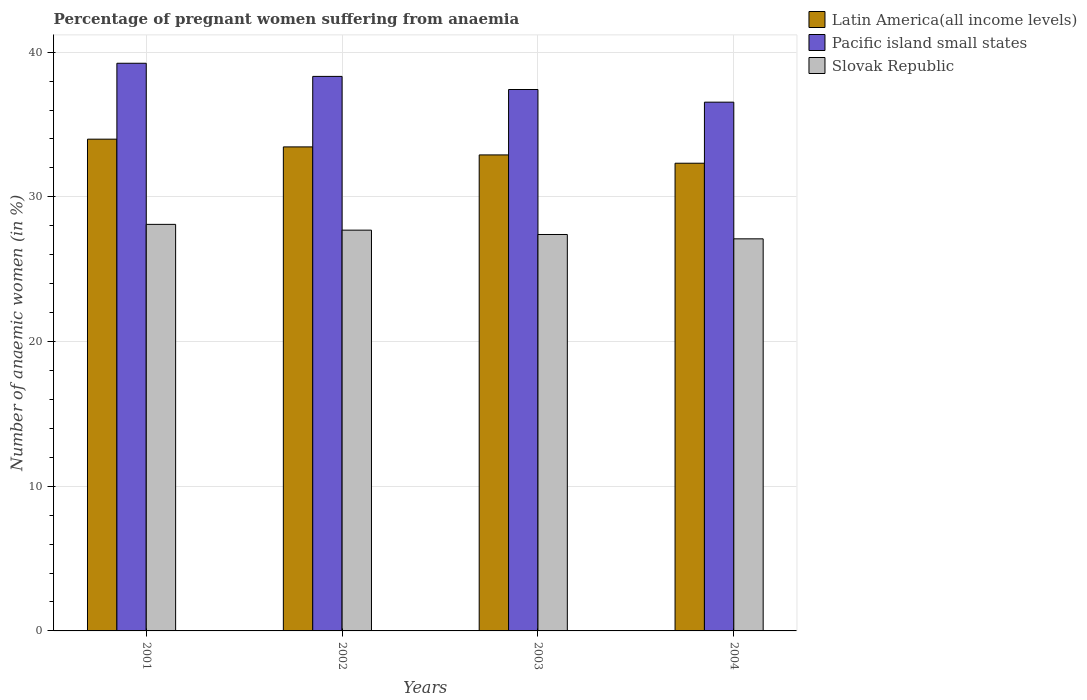How many different coloured bars are there?
Give a very brief answer. 3. Are the number of bars on each tick of the X-axis equal?
Keep it short and to the point. Yes. How many bars are there on the 2nd tick from the left?
Your response must be concise. 3. How many bars are there on the 3rd tick from the right?
Provide a short and direct response. 3. What is the number of anaemic women in Pacific island small states in 2002?
Offer a terse response. 38.33. Across all years, what is the maximum number of anaemic women in Latin America(all income levels)?
Ensure brevity in your answer.  33.99. Across all years, what is the minimum number of anaemic women in Latin America(all income levels)?
Ensure brevity in your answer.  32.33. In which year was the number of anaemic women in Latin America(all income levels) maximum?
Provide a short and direct response. 2001. In which year was the number of anaemic women in Pacific island small states minimum?
Make the answer very short. 2004. What is the total number of anaemic women in Latin America(all income levels) in the graph?
Your answer should be very brief. 132.67. What is the difference between the number of anaemic women in Slovak Republic in 2003 and that in 2004?
Provide a short and direct response. 0.3. What is the difference between the number of anaemic women in Pacific island small states in 2003 and the number of anaemic women in Slovak Republic in 2004?
Provide a succinct answer. 10.32. What is the average number of anaemic women in Slovak Republic per year?
Your answer should be very brief. 27.57. In the year 2002, what is the difference between the number of anaemic women in Latin America(all income levels) and number of anaemic women in Pacific island small states?
Offer a terse response. -4.87. What is the ratio of the number of anaemic women in Pacific island small states in 2002 to that in 2003?
Your answer should be compact. 1.02. What is the difference between the highest and the second highest number of anaemic women in Slovak Republic?
Make the answer very short. 0.4. What is the difference between the highest and the lowest number of anaemic women in Slovak Republic?
Provide a short and direct response. 1. What does the 2nd bar from the left in 2002 represents?
Offer a terse response. Pacific island small states. What does the 2nd bar from the right in 2004 represents?
Provide a short and direct response. Pacific island small states. How many years are there in the graph?
Provide a short and direct response. 4. How many legend labels are there?
Keep it short and to the point. 3. What is the title of the graph?
Make the answer very short. Percentage of pregnant women suffering from anaemia. Does "Qatar" appear as one of the legend labels in the graph?
Your answer should be compact. No. What is the label or title of the X-axis?
Make the answer very short. Years. What is the label or title of the Y-axis?
Give a very brief answer. Number of anaemic women (in %). What is the Number of anaemic women (in %) of Latin America(all income levels) in 2001?
Offer a very short reply. 33.99. What is the Number of anaemic women (in %) in Pacific island small states in 2001?
Your answer should be very brief. 39.23. What is the Number of anaemic women (in %) in Slovak Republic in 2001?
Your answer should be compact. 28.1. What is the Number of anaemic women (in %) in Latin America(all income levels) in 2002?
Ensure brevity in your answer.  33.45. What is the Number of anaemic women (in %) in Pacific island small states in 2002?
Give a very brief answer. 38.33. What is the Number of anaemic women (in %) of Slovak Republic in 2002?
Make the answer very short. 27.7. What is the Number of anaemic women (in %) of Latin America(all income levels) in 2003?
Offer a very short reply. 32.9. What is the Number of anaemic women (in %) in Pacific island small states in 2003?
Your response must be concise. 37.42. What is the Number of anaemic women (in %) in Slovak Republic in 2003?
Make the answer very short. 27.4. What is the Number of anaemic women (in %) of Latin America(all income levels) in 2004?
Your response must be concise. 32.33. What is the Number of anaemic women (in %) in Pacific island small states in 2004?
Ensure brevity in your answer.  36.55. What is the Number of anaemic women (in %) of Slovak Republic in 2004?
Your response must be concise. 27.1. Across all years, what is the maximum Number of anaemic women (in %) in Latin America(all income levels)?
Offer a terse response. 33.99. Across all years, what is the maximum Number of anaemic women (in %) of Pacific island small states?
Offer a very short reply. 39.23. Across all years, what is the maximum Number of anaemic women (in %) in Slovak Republic?
Ensure brevity in your answer.  28.1. Across all years, what is the minimum Number of anaemic women (in %) in Latin America(all income levels)?
Your answer should be very brief. 32.33. Across all years, what is the minimum Number of anaemic women (in %) of Pacific island small states?
Provide a succinct answer. 36.55. Across all years, what is the minimum Number of anaemic women (in %) of Slovak Republic?
Keep it short and to the point. 27.1. What is the total Number of anaemic women (in %) of Latin America(all income levels) in the graph?
Make the answer very short. 132.67. What is the total Number of anaemic women (in %) in Pacific island small states in the graph?
Offer a very short reply. 151.53. What is the total Number of anaemic women (in %) of Slovak Republic in the graph?
Your answer should be very brief. 110.3. What is the difference between the Number of anaemic women (in %) in Latin America(all income levels) in 2001 and that in 2002?
Give a very brief answer. 0.53. What is the difference between the Number of anaemic women (in %) of Pacific island small states in 2001 and that in 2002?
Provide a short and direct response. 0.91. What is the difference between the Number of anaemic women (in %) in Slovak Republic in 2001 and that in 2002?
Ensure brevity in your answer.  0.4. What is the difference between the Number of anaemic women (in %) of Latin America(all income levels) in 2001 and that in 2003?
Provide a succinct answer. 1.09. What is the difference between the Number of anaemic women (in %) of Pacific island small states in 2001 and that in 2003?
Your response must be concise. 1.81. What is the difference between the Number of anaemic women (in %) of Slovak Republic in 2001 and that in 2003?
Make the answer very short. 0.7. What is the difference between the Number of anaemic women (in %) of Latin America(all income levels) in 2001 and that in 2004?
Give a very brief answer. 1.66. What is the difference between the Number of anaemic women (in %) in Pacific island small states in 2001 and that in 2004?
Give a very brief answer. 2.69. What is the difference between the Number of anaemic women (in %) in Latin America(all income levels) in 2002 and that in 2003?
Provide a succinct answer. 0.55. What is the difference between the Number of anaemic women (in %) of Pacific island small states in 2002 and that in 2003?
Provide a succinct answer. 0.91. What is the difference between the Number of anaemic women (in %) of Slovak Republic in 2002 and that in 2003?
Ensure brevity in your answer.  0.3. What is the difference between the Number of anaemic women (in %) in Latin America(all income levels) in 2002 and that in 2004?
Provide a succinct answer. 1.13. What is the difference between the Number of anaemic women (in %) in Pacific island small states in 2002 and that in 2004?
Your response must be concise. 1.78. What is the difference between the Number of anaemic women (in %) in Latin America(all income levels) in 2003 and that in 2004?
Keep it short and to the point. 0.57. What is the difference between the Number of anaemic women (in %) in Pacific island small states in 2003 and that in 2004?
Provide a short and direct response. 0.87. What is the difference between the Number of anaemic women (in %) of Slovak Republic in 2003 and that in 2004?
Provide a succinct answer. 0.3. What is the difference between the Number of anaemic women (in %) in Latin America(all income levels) in 2001 and the Number of anaemic women (in %) in Pacific island small states in 2002?
Provide a succinct answer. -4.34. What is the difference between the Number of anaemic women (in %) of Latin America(all income levels) in 2001 and the Number of anaemic women (in %) of Slovak Republic in 2002?
Offer a terse response. 6.29. What is the difference between the Number of anaemic women (in %) in Pacific island small states in 2001 and the Number of anaemic women (in %) in Slovak Republic in 2002?
Make the answer very short. 11.53. What is the difference between the Number of anaemic women (in %) of Latin America(all income levels) in 2001 and the Number of anaemic women (in %) of Pacific island small states in 2003?
Your response must be concise. -3.43. What is the difference between the Number of anaemic women (in %) of Latin America(all income levels) in 2001 and the Number of anaemic women (in %) of Slovak Republic in 2003?
Provide a succinct answer. 6.59. What is the difference between the Number of anaemic women (in %) of Pacific island small states in 2001 and the Number of anaemic women (in %) of Slovak Republic in 2003?
Your response must be concise. 11.83. What is the difference between the Number of anaemic women (in %) of Latin America(all income levels) in 2001 and the Number of anaemic women (in %) of Pacific island small states in 2004?
Provide a succinct answer. -2.56. What is the difference between the Number of anaemic women (in %) in Latin America(all income levels) in 2001 and the Number of anaemic women (in %) in Slovak Republic in 2004?
Provide a succinct answer. 6.89. What is the difference between the Number of anaemic women (in %) of Pacific island small states in 2001 and the Number of anaemic women (in %) of Slovak Republic in 2004?
Keep it short and to the point. 12.13. What is the difference between the Number of anaemic women (in %) in Latin America(all income levels) in 2002 and the Number of anaemic women (in %) in Pacific island small states in 2003?
Your answer should be very brief. -3.97. What is the difference between the Number of anaemic women (in %) of Latin America(all income levels) in 2002 and the Number of anaemic women (in %) of Slovak Republic in 2003?
Give a very brief answer. 6.05. What is the difference between the Number of anaemic women (in %) of Pacific island small states in 2002 and the Number of anaemic women (in %) of Slovak Republic in 2003?
Give a very brief answer. 10.93. What is the difference between the Number of anaemic women (in %) of Latin America(all income levels) in 2002 and the Number of anaemic women (in %) of Pacific island small states in 2004?
Offer a very short reply. -3.09. What is the difference between the Number of anaemic women (in %) of Latin America(all income levels) in 2002 and the Number of anaemic women (in %) of Slovak Republic in 2004?
Your response must be concise. 6.35. What is the difference between the Number of anaemic women (in %) in Pacific island small states in 2002 and the Number of anaemic women (in %) in Slovak Republic in 2004?
Make the answer very short. 11.23. What is the difference between the Number of anaemic women (in %) in Latin America(all income levels) in 2003 and the Number of anaemic women (in %) in Pacific island small states in 2004?
Your answer should be very brief. -3.65. What is the difference between the Number of anaemic women (in %) in Latin America(all income levels) in 2003 and the Number of anaemic women (in %) in Slovak Republic in 2004?
Make the answer very short. 5.8. What is the difference between the Number of anaemic women (in %) of Pacific island small states in 2003 and the Number of anaemic women (in %) of Slovak Republic in 2004?
Your answer should be very brief. 10.32. What is the average Number of anaemic women (in %) in Latin America(all income levels) per year?
Provide a succinct answer. 33.17. What is the average Number of anaemic women (in %) of Pacific island small states per year?
Ensure brevity in your answer.  37.88. What is the average Number of anaemic women (in %) in Slovak Republic per year?
Provide a short and direct response. 27.57. In the year 2001, what is the difference between the Number of anaemic women (in %) in Latin America(all income levels) and Number of anaemic women (in %) in Pacific island small states?
Keep it short and to the point. -5.25. In the year 2001, what is the difference between the Number of anaemic women (in %) in Latin America(all income levels) and Number of anaemic women (in %) in Slovak Republic?
Offer a very short reply. 5.89. In the year 2001, what is the difference between the Number of anaemic women (in %) in Pacific island small states and Number of anaemic women (in %) in Slovak Republic?
Your response must be concise. 11.13. In the year 2002, what is the difference between the Number of anaemic women (in %) of Latin America(all income levels) and Number of anaemic women (in %) of Pacific island small states?
Keep it short and to the point. -4.87. In the year 2002, what is the difference between the Number of anaemic women (in %) in Latin America(all income levels) and Number of anaemic women (in %) in Slovak Republic?
Make the answer very short. 5.75. In the year 2002, what is the difference between the Number of anaemic women (in %) in Pacific island small states and Number of anaemic women (in %) in Slovak Republic?
Give a very brief answer. 10.63. In the year 2003, what is the difference between the Number of anaemic women (in %) of Latin America(all income levels) and Number of anaemic women (in %) of Pacific island small states?
Make the answer very short. -4.52. In the year 2003, what is the difference between the Number of anaemic women (in %) in Latin America(all income levels) and Number of anaemic women (in %) in Slovak Republic?
Your response must be concise. 5.5. In the year 2003, what is the difference between the Number of anaemic women (in %) of Pacific island small states and Number of anaemic women (in %) of Slovak Republic?
Give a very brief answer. 10.02. In the year 2004, what is the difference between the Number of anaemic women (in %) of Latin America(all income levels) and Number of anaemic women (in %) of Pacific island small states?
Your response must be concise. -4.22. In the year 2004, what is the difference between the Number of anaemic women (in %) in Latin America(all income levels) and Number of anaemic women (in %) in Slovak Republic?
Your answer should be compact. 5.23. In the year 2004, what is the difference between the Number of anaemic women (in %) in Pacific island small states and Number of anaemic women (in %) in Slovak Republic?
Provide a short and direct response. 9.45. What is the ratio of the Number of anaemic women (in %) of Latin America(all income levels) in 2001 to that in 2002?
Give a very brief answer. 1.02. What is the ratio of the Number of anaemic women (in %) in Pacific island small states in 2001 to that in 2002?
Provide a succinct answer. 1.02. What is the ratio of the Number of anaemic women (in %) of Slovak Republic in 2001 to that in 2002?
Offer a very short reply. 1.01. What is the ratio of the Number of anaemic women (in %) in Latin America(all income levels) in 2001 to that in 2003?
Keep it short and to the point. 1.03. What is the ratio of the Number of anaemic women (in %) in Pacific island small states in 2001 to that in 2003?
Provide a short and direct response. 1.05. What is the ratio of the Number of anaemic women (in %) of Slovak Republic in 2001 to that in 2003?
Give a very brief answer. 1.03. What is the ratio of the Number of anaemic women (in %) of Latin America(all income levels) in 2001 to that in 2004?
Your response must be concise. 1.05. What is the ratio of the Number of anaemic women (in %) in Pacific island small states in 2001 to that in 2004?
Offer a very short reply. 1.07. What is the ratio of the Number of anaemic women (in %) in Slovak Republic in 2001 to that in 2004?
Give a very brief answer. 1.04. What is the ratio of the Number of anaemic women (in %) in Latin America(all income levels) in 2002 to that in 2003?
Offer a very short reply. 1.02. What is the ratio of the Number of anaemic women (in %) of Pacific island small states in 2002 to that in 2003?
Offer a very short reply. 1.02. What is the ratio of the Number of anaemic women (in %) in Slovak Republic in 2002 to that in 2003?
Offer a terse response. 1.01. What is the ratio of the Number of anaemic women (in %) in Latin America(all income levels) in 2002 to that in 2004?
Make the answer very short. 1.03. What is the ratio of the Number of anaemic women (in %) of Pacific island small states in 2002 to that in 2004?
Ensure brevity in your answer.  1.05. What is the ratio of the Number of anaemic women (in %) in Slovak Republic in 2002 to that in 2004?
Provide a succinct answer. 1.02. What is the ratio of the Number of anaemic women (in %) in Latin America(all income levels) in 2003 to that in 2004?
Ensure brevity in your answer.  1.02. What is the ratio of the Number of anaemic women (in %) in Pacific island small states in 2003 to that in 2004?
Offer a very short reply. 1.02. What is the ratio of the Number of anaemic women (in %) of Slovak Republic in 2003 to that in 2004?
Provide a short and direct response. 1.01. What is the difference between the highest and the second highest Number of anaemic women (in %) in Latin America(all income levels)?
Offer a very short reply. 0.53. What is the difference between the highest and the second highest Number of anaemic women (in %) of Pacific island small states?
Offer a very short reply. 0.91. What is the difference between the highest and the second highest Number of anaemic women (in %) in Slovak Republic?
Offer a very short reply. 0.4. What is the difference between the highest and the lowest Number of anaemic women (in %) in Latin America(all income levels)?
Make the answer very short. 1.66. What is the difference between the highest and the lowest Number of anaemic women (in %) of Pacific island small states?
Ensure brevity in your answer.  2.69. 